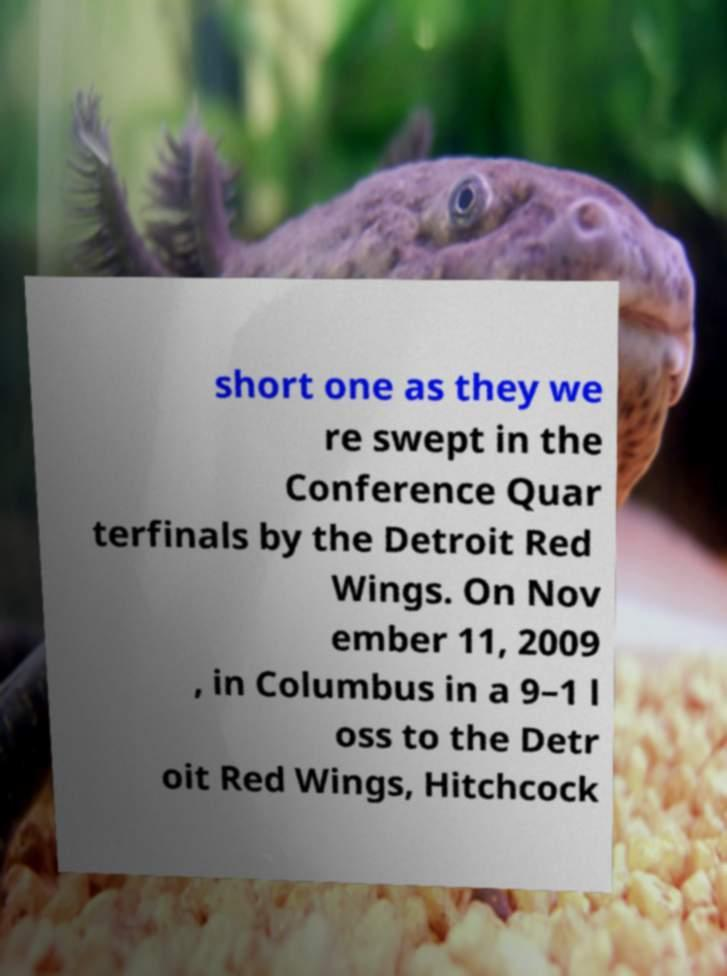There's text embedded in this image that I need extracted. Can you transcribe it verbatim? short one as they we re swept in the Conference Quar terfinals by the Detroit Red Wings. On Nov ember 11, 2009 , in Columbus in a 9–1 l oss to the Detr oit Red Wings, Hitchcock 